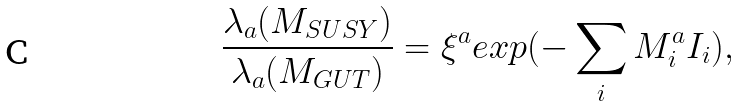Convert formula to latex. <formula><loc_0><loc_0><loc_500><loc_500>\frac { \lambda _ { a } ( M _ { S U S Y } ) } { \lambda _ { a } ( M _ { G U T } ) } = \xi ^ { a } e x p ( - \sum _ { i } M _ { i } ^ { a } I _ { i } ) ,</formula> 